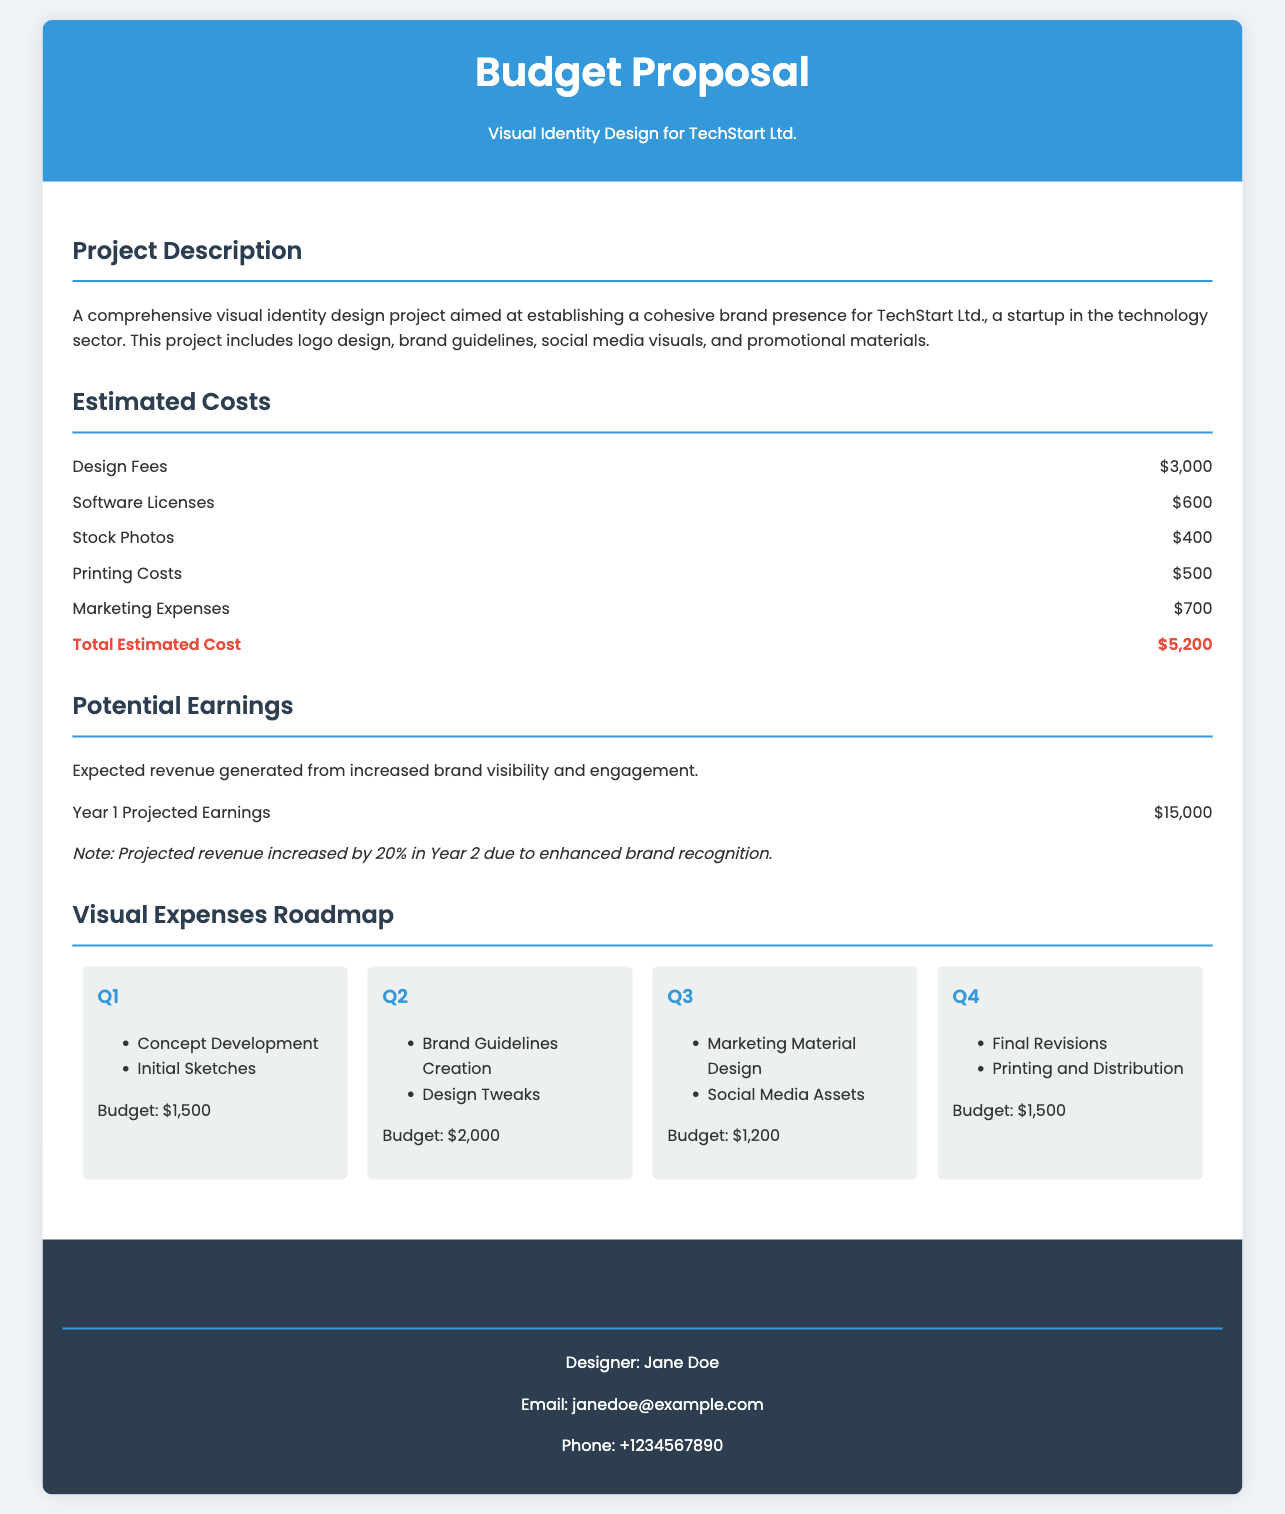What is the total estimated cost? The total estimated cost is provided in the document under the estimated costs section, summing all listed expenses.
Answer: $5,200 Who is the designer listed in the contact information? The document specifies the name of the designer under the contact section.
Answer: Jane Doe What is the projected earnings for Year 1? The document states the expected revenue generated in Year 1 under the potential earnings section.
Answer: $15,000 What is the budget for Q2? The specific budget for Q2 is mentioned in the visual expenses roadmap section.
Answer: $2,000 What items are included in Q3? The roadmap outlines the activities planned for Q3, detailing items listed under that quarter.
Answer: Marketing Material Design, Social Media Assets What type of project is this budget proposal for? The document describes the nature of the project in the project description section.
Answer: Visual identity design What are the printing costs listed? Printing costs are included among the estimated costs in the budget proposal.
Answer: $500 By what percentage are earnings expected to increase in Year 2? The document notes the anticipated percentage increase in earnings in the potential earnings section.
Answer: 20% 